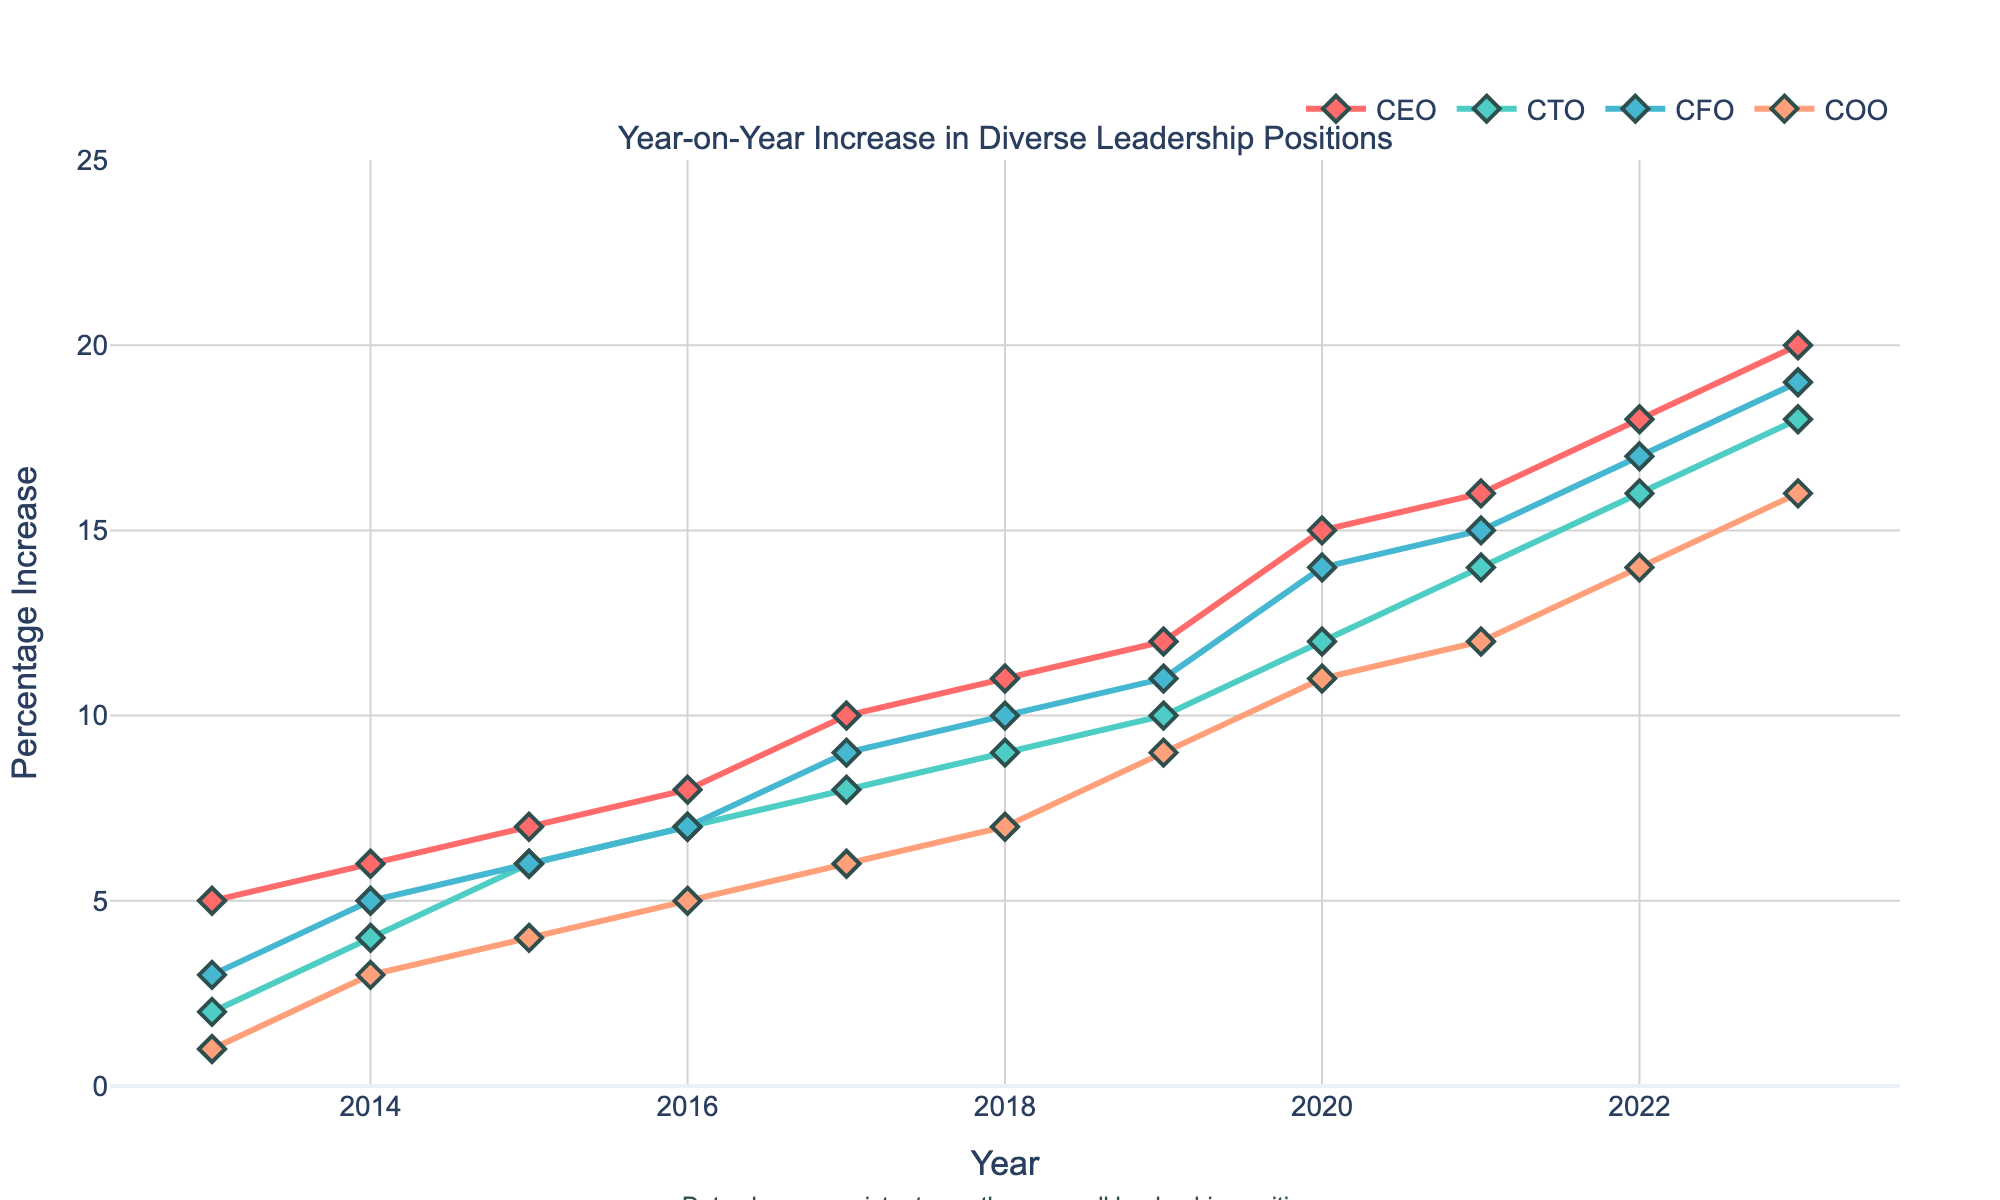what is the overall trend for the CEO position from 2013 to 2023? Observing the plot, the percentage increase for the CEO position steadily rises from 5% in 2013 to 20% in 2023.
Answer: A consistent increase Which year saw the highest increase in the CTO position? The highest point on the CTO line occurs in 2023 with an 18% increase.
Answer: 2023 What is the difference between the CFO and COO positions' percentage increase in 2021? In 2021, the CFO position shows a 15% increase, while the COO position shows a 12% increase. The difference is 15% - 12% = 3%.
Answer: 3% chart specifically question If we wanted to find an outlier or deviation, which leadership position or year might indicate this? By examining the consistency in the plotted lines, the entire trend for all positions appears steady, with the CEO position showing a more rapid increase post-2019, particularly noticeable in 2020.
Answer: CEO in 2020 Did any leadership position experience a percentage increase plateau between 2016 and 2018? From the visual plot, all leadership positions demonstrate a clear upward trend without a plateau; however, CTO and COO have a smoother, more consistent growth.
Answer: No What is the average percentage increase for the COO position from 2018 to 2023? The percentage increases for COO from 2018 to 2023 are 7%, 9%, 11%, 12%, 14%, and 16%. Sum these values and divide by the number of years: (7 + 9 + 11 + 12 + 14 + 16) / 6 = 11.5%.
Answer: 11.5% Which leadership position had the smallest percentage increase in the first year displayed, 2013? In 2013, the COO position had the smallest percentage increase at 1%.
Answer: COO By how much did the percentage increase for the CEO position in 2023 exceed that in 2014? The CEO's percentage increase in 2014 was 6%, and in 2023 it was 20%. The difference is 20% - 6% = 14%.
Answer: 14% Among all leadership positions, which one had the most significant annual growth in any single year, and what was the value? The CEO position experienced the most significant growth in 2020, with a percentage increase rising from 12% in 2019 to 15% in 2020.
Answer: CEO, 3% 